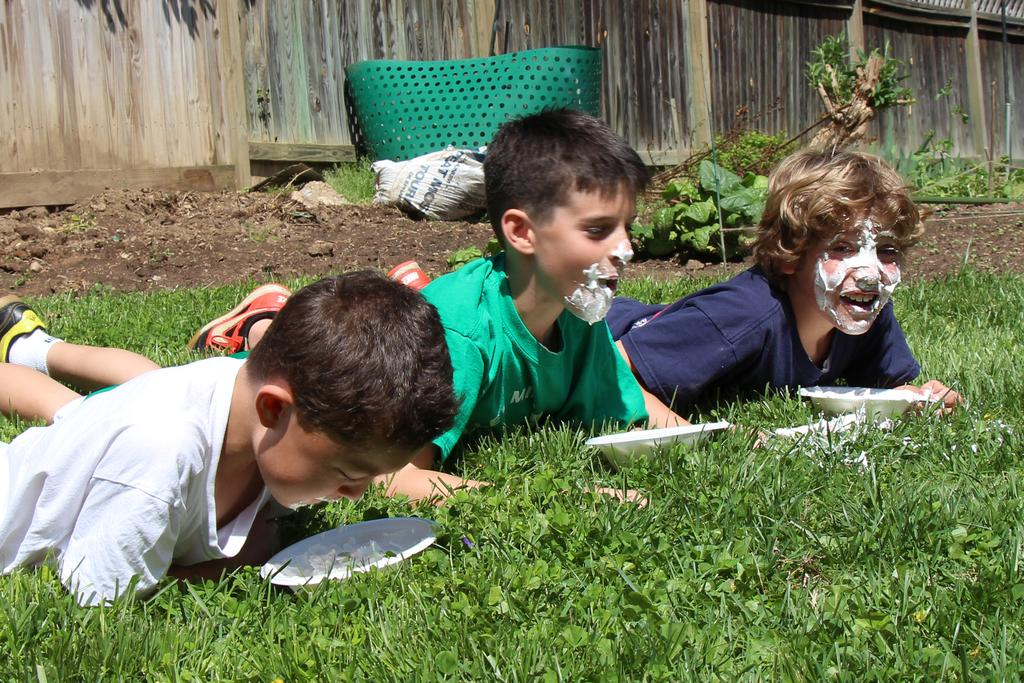How many boys are in the image? There are three boys in the image. What are the boys doing in the image? The boys are laying on the grass. What objects are in front of the boys? There are bowls in front of the boys. What can be seen in the background of the image? There is a wooden wall, a bag, and a green object in the background. What type of rice is being served in the bowls in the image? There is no rice present in the image; the bowls are empty. Can you see a kitty playing with the boys in the image? There is no kitty present in the image; the boys are laying on the grass without any animals. 